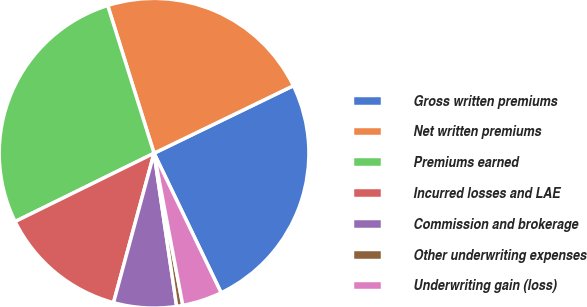Convert chart to OTSL. <chart><loc_0><loc_0><loc_500><loc_500><pie_chart><fcel>Gross written premiums<fcel>Net written premiums<fcel>Premiums earned<fcel>Incurred losses and LAE<fcel>Commission and brokerage<fcel>Other underwriting expenses<fcel>Underwriting gain (loss)<nl><fcel>25.05%<fcel>22.66%<fcel>27.44%<fcel>13.51%<fcel>6.55%<fcel>0.64%<fcel>4.16%<nl></chart> 